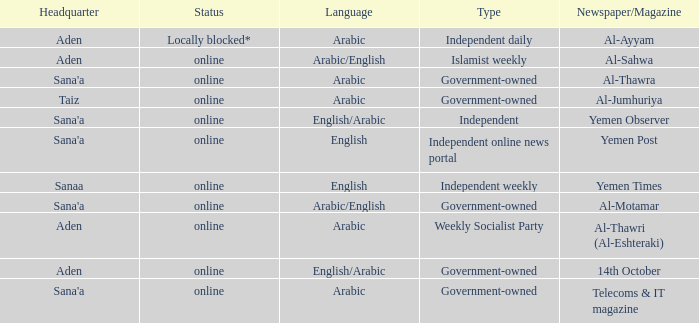What is the condition when the newspaper/magazine is al-thawra? Online. 